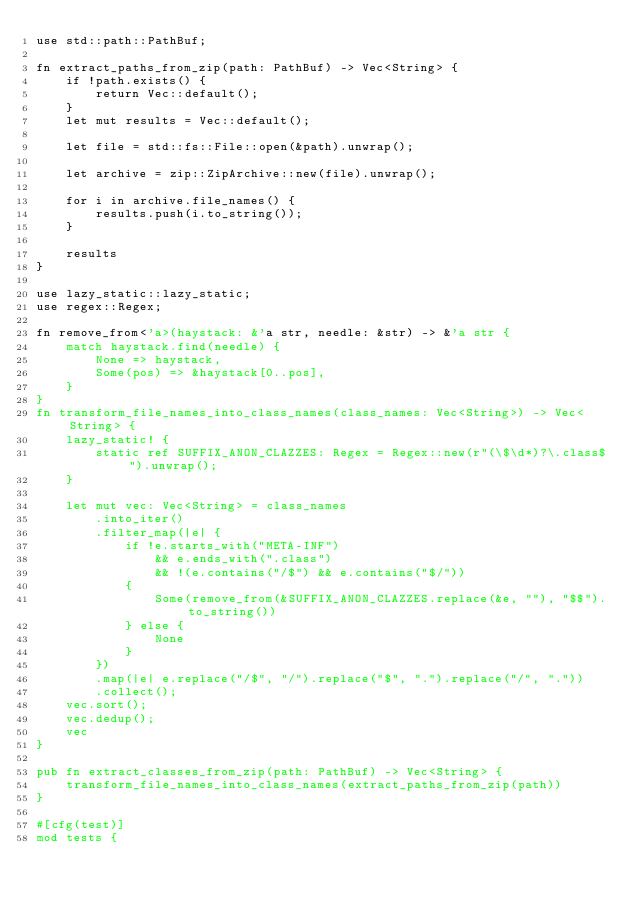<code> <loc_0><loc_0><loc_500><loc_500><_Rust_>use std::path::PathBuf;

fn extract_paths_from_zip(path: PathBuf) -> Vec<String> {
    if !path.exists() {
        return Vec::default();
    }
    let mut results = Vec::default();

    let file = std::fs::File::open(&path).unwrap();

    let archive = zip::ZipArchive::new(file).unwrap();

    for i in archive.file_names() {
        results.push(i.to_string());
    }

    results
}

use lazy_static::lazy_static;
use regex::Regex;

fn remove_from<'a>(haystack: &'a str, needle: &str) -> &'a str {
    match haystack.find(needle) {
        None => haystack,
        Some(pos) => &haystack[0..pos],
    }
}
fn transform_file_names_into_class_names(class_names: Vec<String>) -> Vec<String> {
    lazy_static! {
        static ref SUFFIX_ANON_CLAZZES: Regex = Regex::new(r"(\$\d*)?\.class$").unwrap();
    }

    let mut vec: Vec<String> = class_names
        .into_iter()
        .filter_map(|e| {
            if !e.starts_with("META-INF")
                && e.ends_with(".class")
                && !(e.contains("/$") && e.contains("$/"))
            {
                Some(remove_from(&SUFFIX_ANON_CLAZZES.replace(&e, ""), "$$").to_string())
            } else {
                None
            }
        })
        .map(|e| e.replace("/$", "/").replace("$", ".").replace("/", "."))
        .collect();
    vec.sort();
    vec.dedup();
    vec
}

pub fn extract_classes_from_zip(path: PathBuf) -> Vec<String> {
    transform_file_names_into_class_names(extract_paths_from_zip(path))
}

#[cfg(test)]
mod tests {</code> 